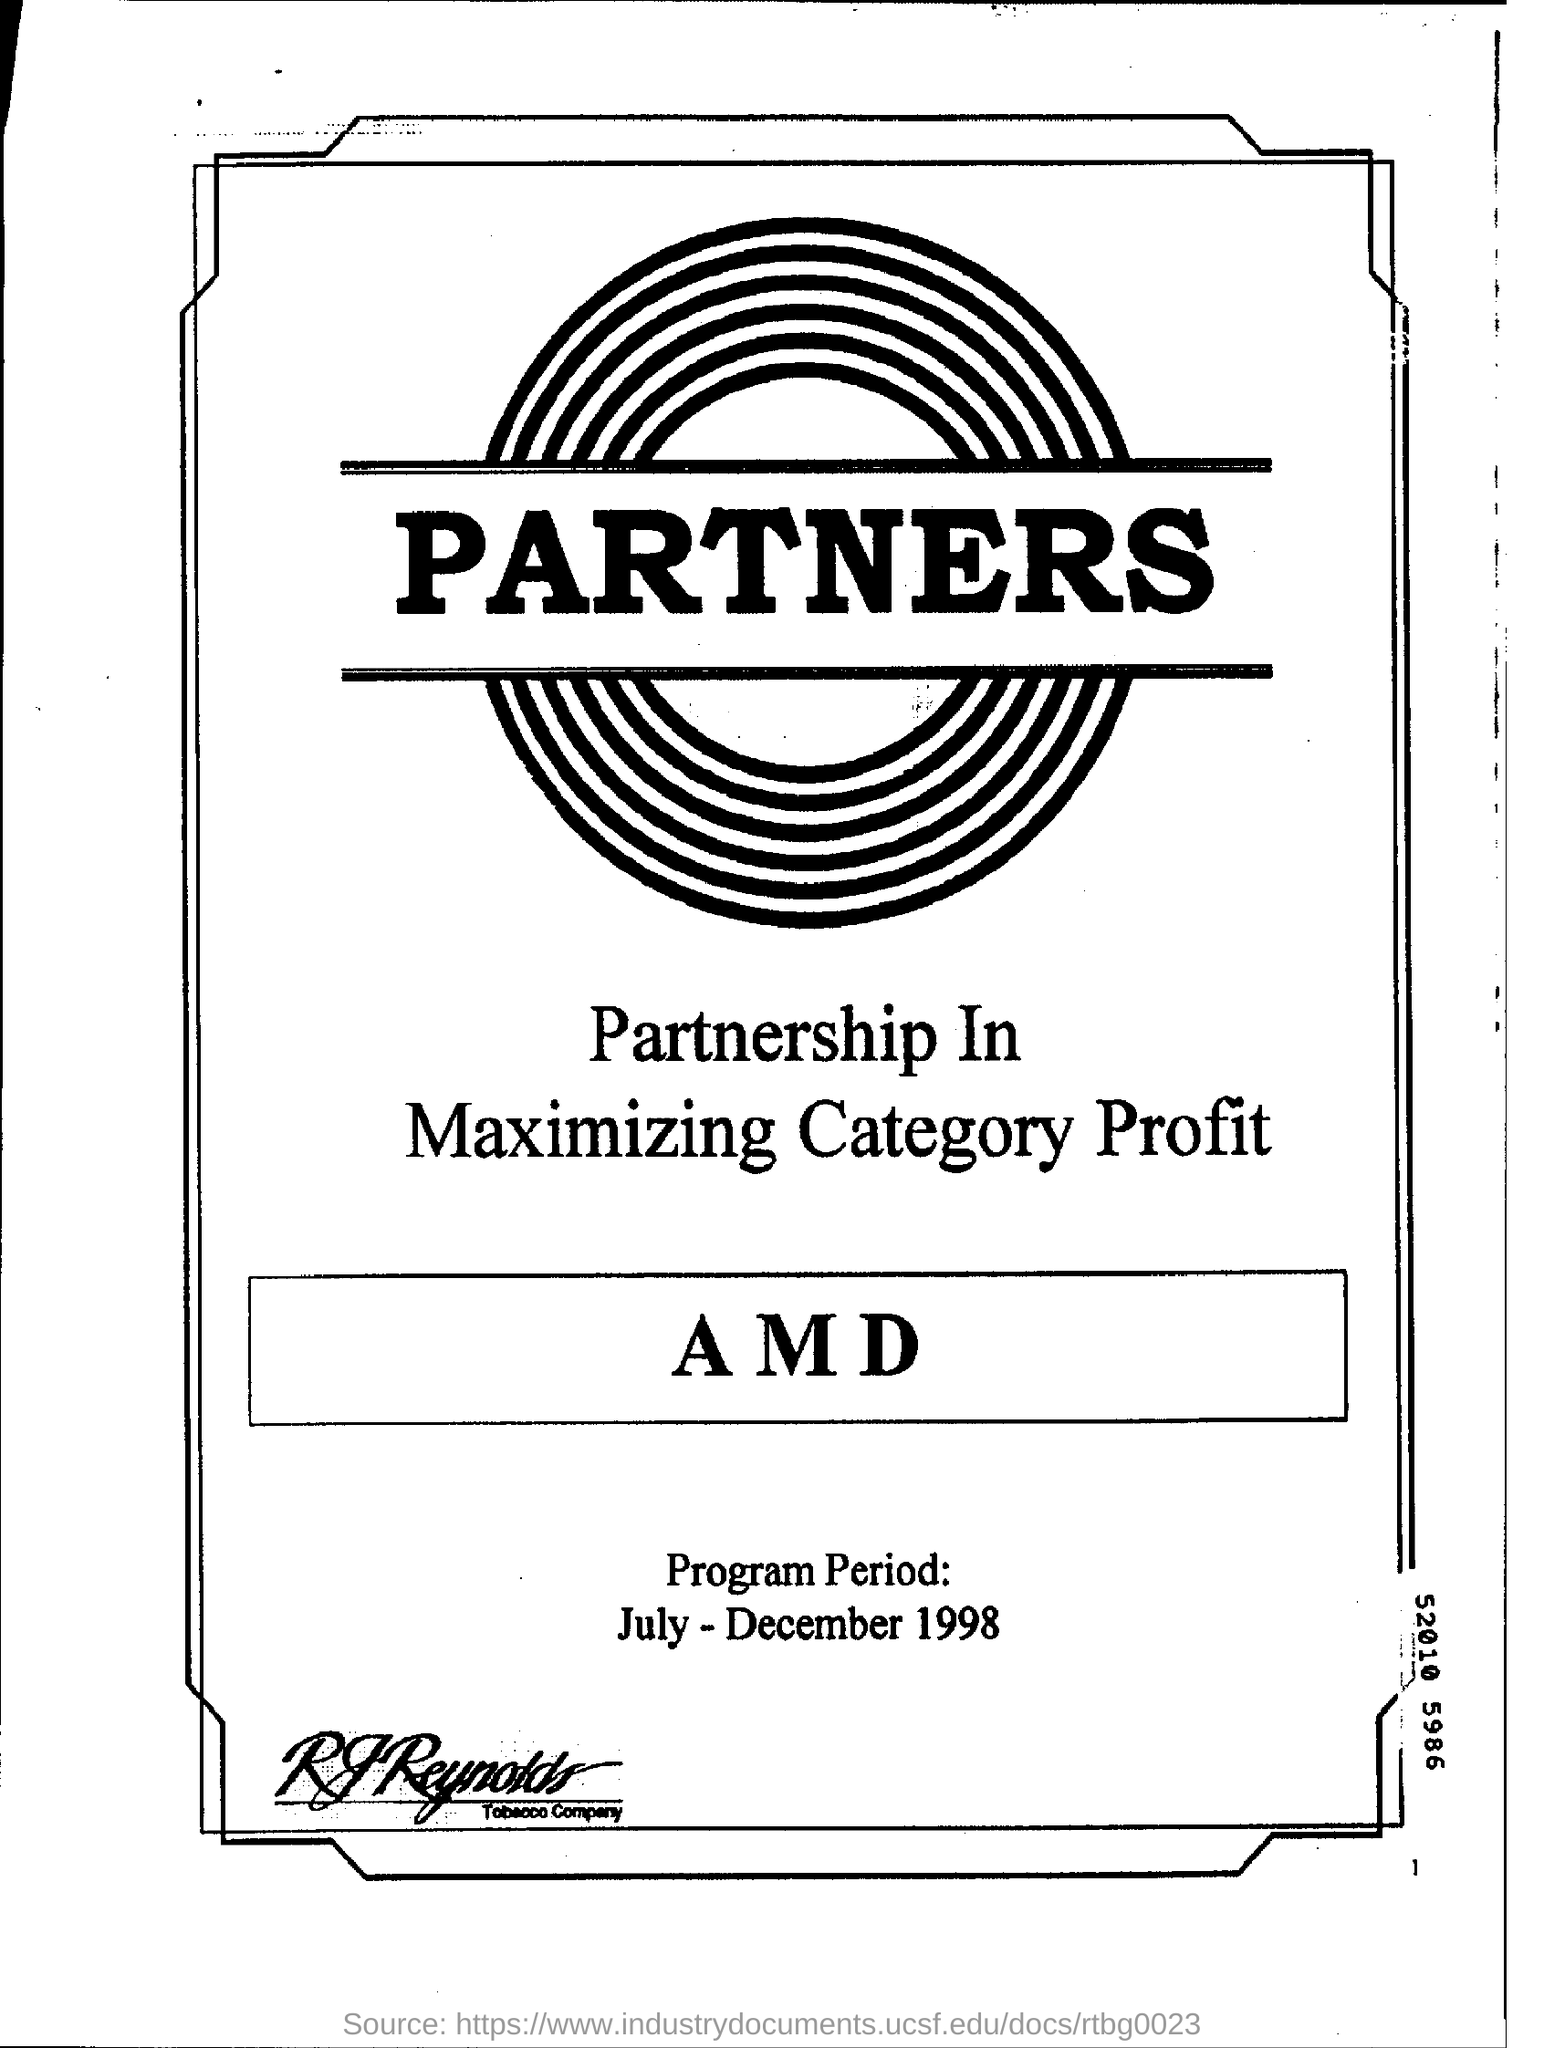Date the program period?
Provide a short and direct response. July - December 1998. 